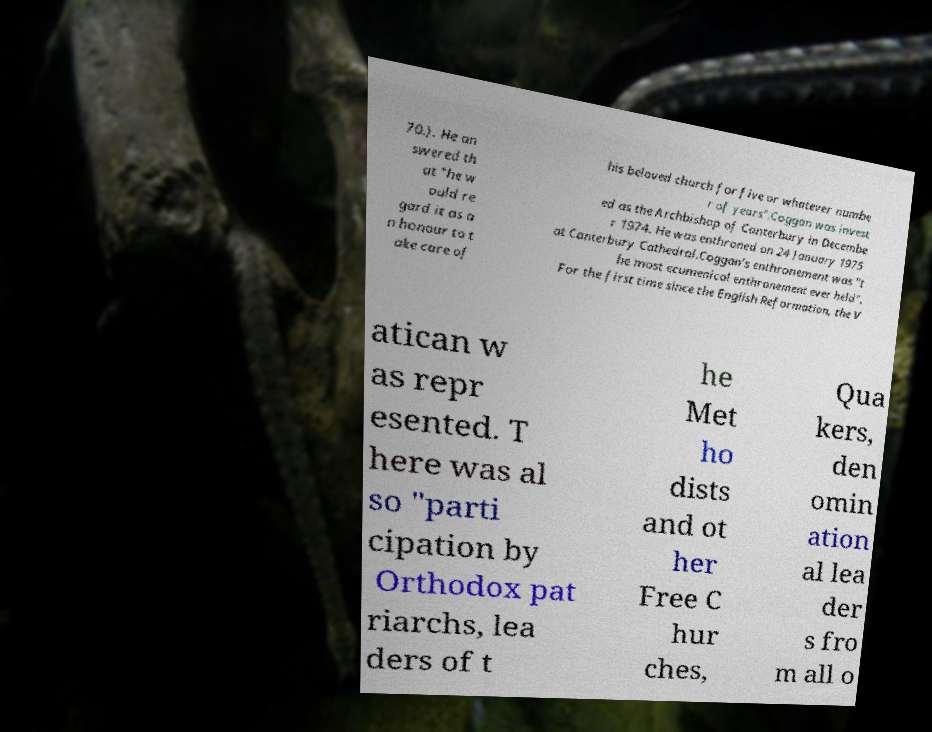Please read and relay the text visible in this image. What does it say? 70.). He an swered th at "he w ould re gard it as a n honour to t ake care of his beloved church for five or whatever numbe r of years".Coggan was invest ed as the Archbishop of Canterbury in Decembe r 1974. He was enthroned on 24 January 1975 at Canterbury Cathedral.Coggan's enthronement was "t he most ecumenical enthronement ever held". For the first time since the English Reformation, the V atican w as repr esented. T here was al so "parti cipation by Orthodox pat riarchs, lea ders of t he Met ho dists and ot her Free C hur ches, Qua kers, den omin ation al lea der s fro m all o 